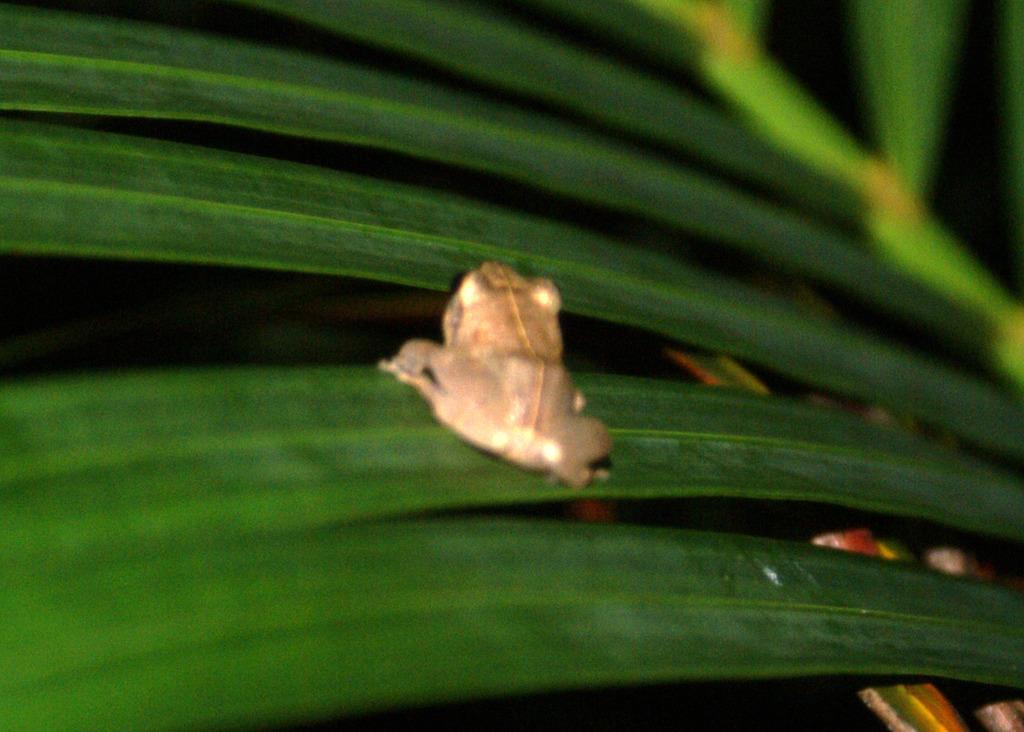In one or two sentences, can you explain what this image depicts? In this image we can see frog and leaves. 